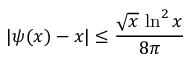<formula> <loc_0><loc_0><loc_500><loc_500>| \psi ( x ) - x | \leq { \frac { { \sqrt { x } } \, \ln ^ { 2 } x } { 8 \pi } }</formula> 